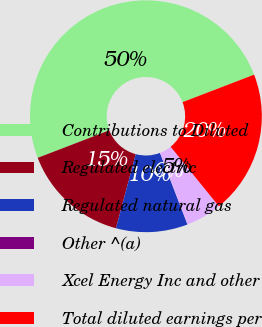Convert chart to OTSL. <chart><loc_0><loc_0><loc_500><loc_500><pie_chart><fcel>Contributions to Diluted<fcel>Regulated electric<fcel>Regulated natural gas<fcel>Other ^(a)<fcel>Xcel Energy Inc and other<fcel>Total diluted earnings per<nl><fcel>50.0%<fcel>15.0%<fcel>10.0%<fcel>0.0%<fcel>5.0%<fcel>20.0%<nl></chart> 